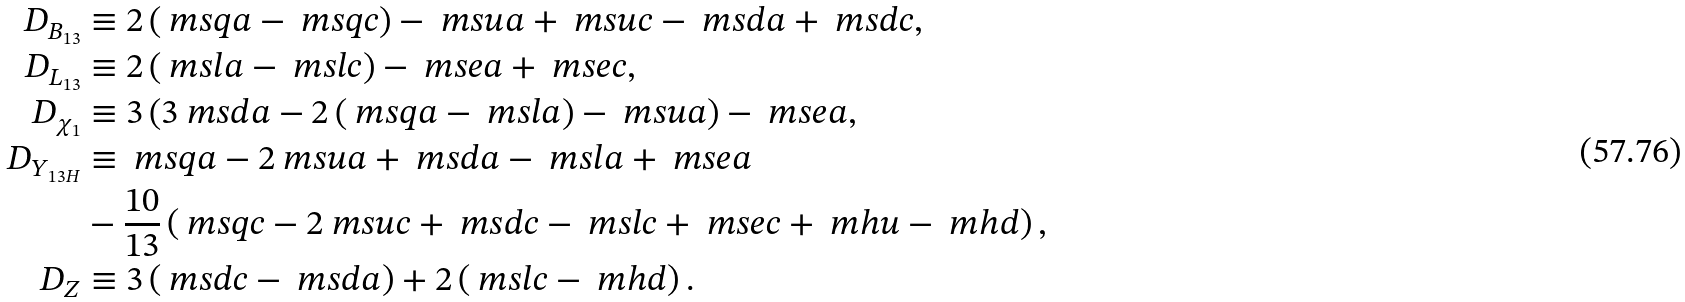<formula> <loc_0><loc_0><loc_500><loc_500>D _ { B _ { 1 3 } } & \equiv 2 \left ( \ m s q a - \ m s q c \right ) - \ m s u a + \ m s u c - \ m s d a + \ m s d c , \\ D _ { L _ { 1 3 } } & \equiv 2 \left ( \ m s l a - \ m s l c \right ) - \ m s e a + \ m s e c , \\ D _ { \chi _ { 1 } } & \equiv 3 \left ( 3 \ m s d a - 2 \left ( \ m s q a - \ m s l a \right ) - \ m s u a \right ) - \ m s e a , \\ D _ { Y _ { 1 3 H } } & \equiv \ m s q a - 2 \ m s u a + \ m s d a - \ m s l a + \ m s e a \\ & - \frac { 1 0 } { 1 3 } \left ( \ m s q c - 2 \ m s u c + \ m s d c - \ m s l c + \ m s e c + \ m h u - \ m h d \right ) , \\ D _ { Z } & \equiv 3 \left ( \ m s d c - \ m s d a \right ) + 2 \left ( \ m s l c - \ m h d \right ) .</formula> 